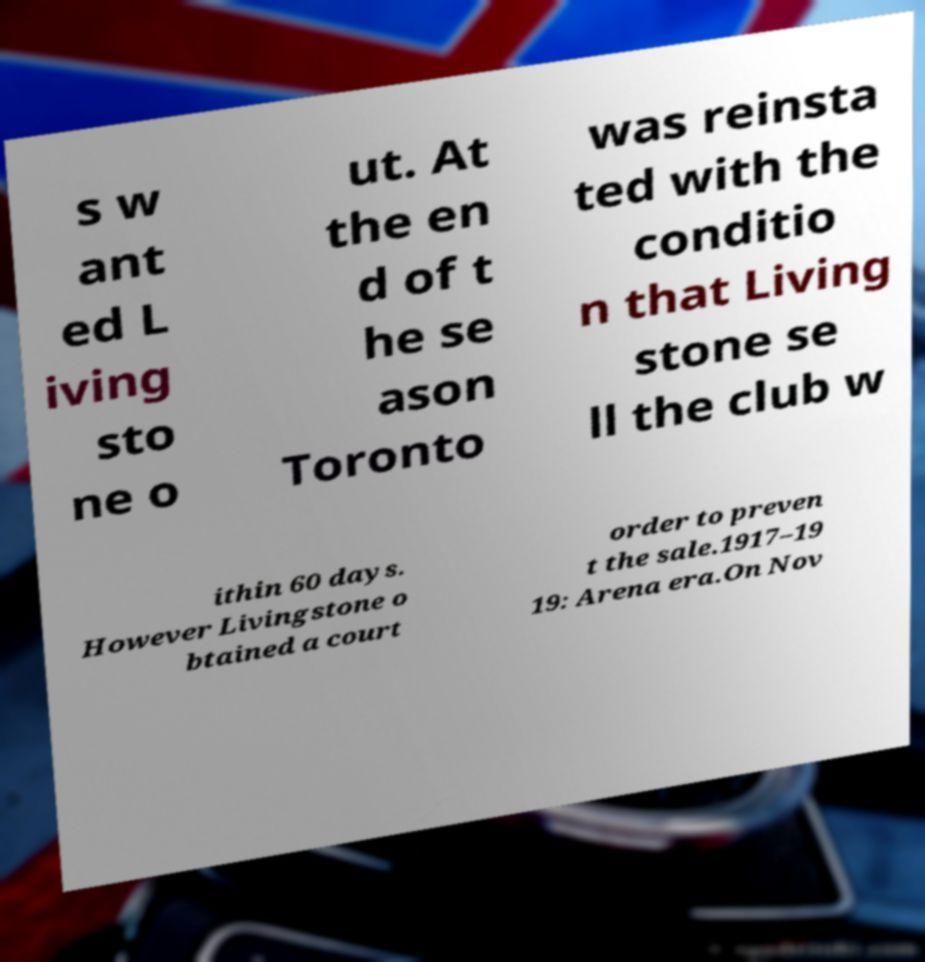Please read and relay the text visible in this image. What does it say? s w ant ed L iving sto ne o ut. At the en d of t he se ason Toronto was reinsta ted with the conditio n that Living stone se ll the club w ithin 60 days. However Livingstone o btained a court order to preven t the sale.1917–19 19: Arena era.On Nov 